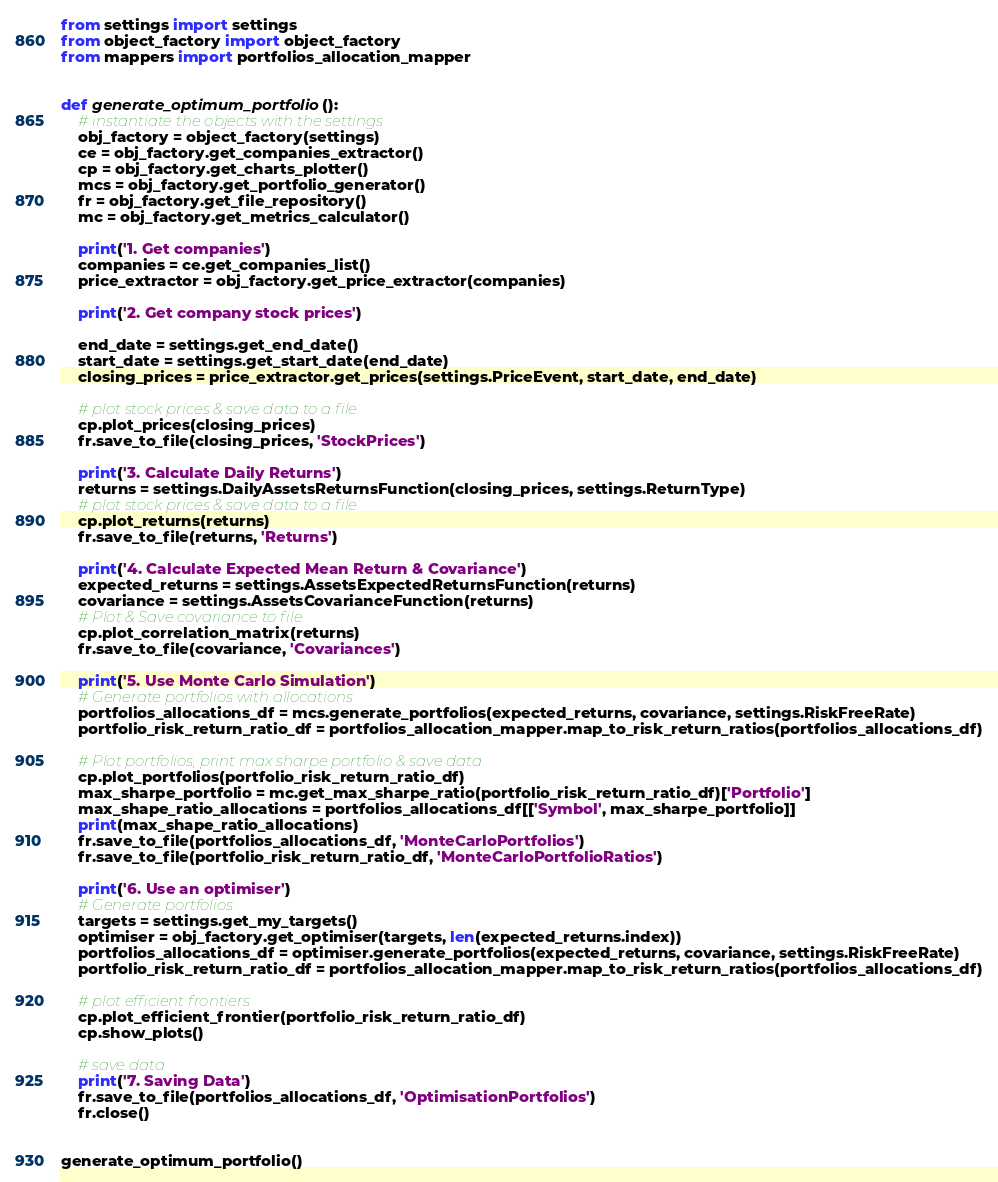<code> <loc_0><loc_0><loc_500><loc_500><_Python_>from settings import settings
from object_factory import object_factory
from mappers import portfolios_allocation_mapper


def generate_optimum_portfolio():
    # instantiate the objects with the settings
    obj_factory = object_factory(settings)
    ce = obj_factory.get_companies_extractor()
    cp = obj_factory.get_charts_plotter()
    mcs = obj_factory.get_portfolio_generator()
    fr = obj_factory.get_file_repository()
    mc = obj_factory.get_metrics_calculator()

    print('1. Get companies')
    companies = ce.get_companies_list()
    price_extractor = obj_factory.get_price_extractor(companies)

    print('2. Get company stock prices')

    end_date = settings.get_end_date()
    start_date = settings.get_start_date(end_date)
    closing_prices = price_extractor.get_prices(settings.PriceEvent, start_date, end_date)

    # plot stock prices & save data to a file
    cp.plot_prices(closing_prices)
    fr.save_to_file(closing_prices, 'StockPrices')

    print('3. Calculate Daily Returns')
    returns = settings.DailyAssetsReturnsFunction(closing_prices, settings.ReturnType)
    # plot stock prices & save data to a file
    cp.plot_returns(returns)
    fr.save_to_file(returns, 'Returns')

    print('4. Calculate Expected Mean Return & Covariance')
    expected_returns = settings.AssetsExpectedReturnsFunction(returns)
    covariance = settings.AssetsCovarianceFunction(returns)
    # Plot & Save covariance to file
    cp.plot_correlation_matrix(returns)
    fr.save_to_file(covariance, 'Covariances')

    print('5. Use Monte Carlo Simulation')
    # Generate portfolios with allocations
    portfolios_allocations_df = mcs.generate_portfolios(expected_returns, covariance, settings.RiskFreeRate)
    portfolio_risk_return_ratio_df = portfolios_allocation_mapper.map_to_risk_return_ratios(portfolios_allocations_df)

    # Plot portfolios, print max sharpe portfolio & save data
    cp.plot_portfolios(portfolio_risk_return_ratio_df)
    max_sharpe_portfolio = mc.get_max_sharpe_ratio(portfolio_risk_return_ratio_df)['Portfolio']
    max_shape_ratio_allocations = portfolios_allocations_df[['Symbol', max_sharpe_portfolio]]
    print(max_shape_ratio_allocations)
    fr.save_to_file(portfolios_allocations_df, 'MonteCarloPortfolios')
    fr.save_to_file(portfolio_risk_return_ratio_df, 'MonteCarloPortfolioRatios')

    print('6. Use an optimiser')
    # Generate portfolios
    targets = settings.get_my_targets()
    optimiser = obj_factory.get_optimiser(targets, len(expected_returns.index))
    portfolios_allocations_df = optimiser.generate_portfolios(expected_returns, covariance, settings.RiskFreeRate)
    portfolio_risk_return_ratio_df = portfolios_allocation_mapper.map_to_risk_return_ratios(portfolios_allocations_df)

    # plot efficient frontiers
    cp.plot_efficient_frontier(portfolio_risk_return_ratio_df)
    cp.show_plots()

    # save data
    print('7. Saving Data')
    fr.save_to_file(portfolios_allocations_df, 'OptimisationPortfolios')
    fr.close()


generate_optimum_portfolio()
</code> 